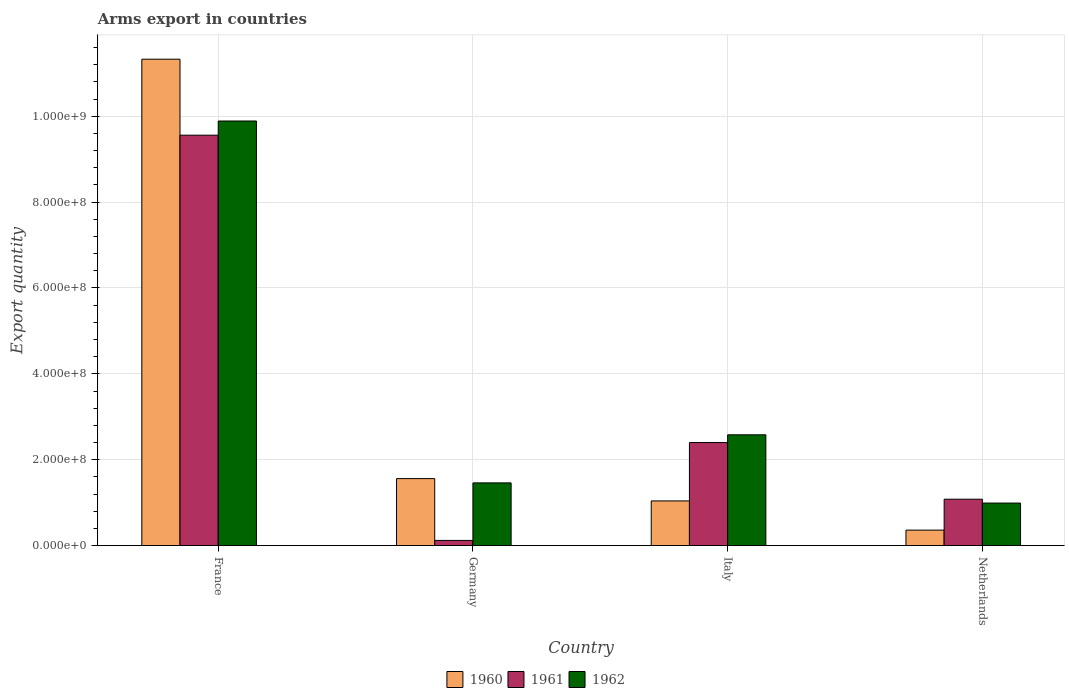How many different coloured bars are there?
Give a very brief answer. 3. How many groups of bars are there?
Provide a succinct answer. 4. How many bars are there on the 3rd tick from the right?
Ensure brevity in your answer.  3. What is the label of the 3rd group of bars from the left?
Provide a succinct answer. Italy. In how many cases, is the number of bars for a given country not equal to the number of legend labels?
Offer a very short reply. 0. What is the total arms export in 1962 in France?
Give a very brief answer. 9.89e+08. Across all countries, what is the maximum total arms export in 1960?
Offer a terse response. 1.13e+09. Across all countries, what is the minimum total arms export in 1962?
Your response must be concise. 9.90e+07. What is the total total arms export in 1962 in the graph?
Offer a very short reply. 1.49e+09. What is the difference between the total arms export in 1961 in France and that in Italy?
Your answer should be compact. 7.16e+08. What is the difference between the total arms export in 1962 in Italy and the total arms export in 1961 in Netherlands?
Make the answer very short. 1.50e+08. What is the average total arms export in 1962 per country?
Offer a terse response. 3.73e+08. What is the difference between the total arms export of/in 1962 and total arms export of/in 1960 in Italy?
Make the answer very short. 1.54e+08. In how many countries, is the total arms export in 1962 greater than 360000000?
Offer a terse response. 1. What is the difference between the highest and the second highest total arms export in 1961?
Give a very brief answer. 7.16e+08. What is the difference between the highest and the lowest total arms export in 1960?
Your answer should be compact. 1.10e+09. In how many countries, is the total arms export in 1962 greater than the average total arms export in 1962 taken over all countries?
Your response must be concise. 1. What does the 1st bar from the right in France represents?
Give a very brief answer. 1962. Is it the case that in every country, the sum of the total arms export in 1960 and total arms export in 1961 is greater than the total arms export in 1962?
Your response must be concise. Yes. Are all the bars in the graph horizontal?
Give a very brief answer. No. Does the graph contain any zero values?
Provide a succinct answer. No. Does the graph contain grids?
Your answer should be very brief. Yes. How many legend labels are there?
Keep it short and to the point. 3. How are the legend labels stacked?
Keep it short and to the point. Horizontal. What is the title of the graph?
Provide a short and direct response. Arms export in countries. What is the label or title of the Y-axis?
Your response must be concise. Export quantity. What is the Export quantity in 1960 in France?
Offer a very short reply. 1.13e+09. What is the Export quantity of 1961 in France?
Offer a terse response. 9.56e+08. What is the Export quantity in 1962 in France?
Keep it short and to the point. 9.89e+08. What is the Export quantity in 1960 in Germany?
Your answer should be very brief. 1.56e+08. What is the Export quantity of 1961 in Germany?
Your response must be concise. 1.20e+07. What is the Export quantity in 1962 in Germany?
Your answer should be compact. 1.46e+08. What is the Export quantity in 1960 in Italy?
Keep it short and to the point. 1.04e+08. What is the Export quantity in 1961 in Italy?
Give a very brief answer. 2.40e+08. What is the Export quantity in 1962 in Italy?
Your answer should be compact. 2.58e+08. What is the Export quantity in 1960 in Netherlands?
Give a very brief answer. 3.60e+07. What is the Export quantity of 1961 in Netherlands?
Offer a terse response. 1.08e+08. What is the Export quantity in 1962 in Netherlands?
Keep it short and to the point. 9.90e+07. Across all countries, what is the maximum Export quantity in 1960?
Your response must be concise. 1.13e+09. Across all countries, what is the maximum Export quantity of 1961?
Offer a terse response. 9.56e+08. Across all countries, what is the maximum Export quantity in 1962?
Provide a short and direct response. 9.89e+08. Across all countries, what is the minimum Export quantity of 1960?
Offer a very short reply. 3.60e+07. Across all countries, what is the minimum Export quantity in 1961?
Provide a succinct answer. 1.20e+07. Across all countries, what is the minimum Export quantity of 1962?
Provide a succinct answer. 9.90e+07. What is the total Export quantity in 1960 in the graph?
Make the answer very short. 1.43e+09. What is the total Export quantity of 1961 in the graph?
Your answer should be compact. 1.32e+09. What is the total Export quantity of 1962 in the graph?
Provide a short and direct response. 1.49e+09. What is the difference between the Export quantity in 1960 in France and that in Germany?
Make the answer very short. 9.77e+08. What is the difference between the Export quantity in 1961 in France and that in Germany?
Your response must be concise. 9.44e+08. What is the difference between the Export quantity of 1962 in France and that in Germany?
Ensure brevity in your answer.  8.43e+08. What is the difference between the Export quantity of 1960 in France and that in Italy?
Offer a terse response. 1.03e+09. What is the difference between the Export quantity of 1961 in France and that in Italy?
Offer a very short reply. 7.16e+08. What is the difference between the Export quantity in 1962 in France and that in Italy?
Provide a succinct answer. 7.31e+08. What is the difference between the Export quantity of 1960 in France and that in Netherlands?
Provide a short and direct response. 1.10e+09. What is the difference between the Export quantity in 1961 in France and that in Netherlands?
Your response must be concise. 8.48e+08. What is the difference between the Export quantity of 1962 in France and that in Netherlands?
Provide a succinct answer. 8.90e+08. What is the difference between the Export quantity of 1960 in Germany and that in Italy?
Keep it short and to the point. 5.20e+07. What is the difference between the Export quantity of 1961 in Germany and that in Italy?
Provide a succinct answer. -2.28e+08. What is the difference between the Export quantity in 1962 in Germany and that in Italy?
Your answer should be very brief. -1.12e+08. What is the difference between the Export quantity in 1960 in Germany and that in Netherlands?
Provide a succinct answer. 1.20e+08. What is the difference between the Export quantity of 1961 in Germany and that in Netherlands?
Provide a succinct answer. -9.60e+07. What is the difference between the Export quantity in 1962 in Germany and that in Netherlands?
Your answer should be compact. 4.70e+07. What is the difference between the Export quantity in 1960 in Italy and that in Netherlands?
Provide a succinct answer. 6.80e+07. What is the difference between the Export quantity in 1961 in Italy and that in Netherlands?
Keep it short and to the point. 1.32e+08. What is the difference between the Export quantity in 1962 in Italy and that in Netherlands?
Your answer should be compact. 1.59e+08. What is the difference between the Export quantity of 1960 in France and the Export quantity of 1961 in Germany?
Keep it short and to the point. 1.12e+09. What is the difference between the Export quantity of 1960 in France and the Export quantity of 1962 in Germany?
Offer a terse response. 9.87e+08. What is the difference between the Export quantity in 1961 in France and the Export quantity in 1962 in Germany?
Your answer should be very brief. 8.10e+08. What is the difference between the Export quantity in 1960 in France and the Export quantity in 1961 in Italy?
Offer a terse response. 8.93e+08. What is the difference between the Export quantity of 1960 in France and the Export quantity of 1962 in Italy?
Give a very brief answer. 8.75e+08. What is the difference between the Export quantity in 1961 in France and the Export quantity in 1962 in Italy?
Your answer should be very brief. 6.98e+08. What is the difference between the Export quantity of 1960 in France and the Export quantity of 1961 in Netherlands?
Make the answer very short. 1.02e+09. What is the difference between the Export quantity in 1960 in France and the Export quantity in 1962 in Netherlands?
Give a very brief answer. 1.03e+09. What is the difference between the Export quantity in 1961 in France and the Export quantity in 1962 in Netherlands?
Keep it short and to the point. 8.57e+08. What is the difference between the Export quantity in 1960 in Germany and the Export quantity in 1961 in Italy?
Provide a short and direct response. -8.40e+07. What is the difference between the Export quantity of 1960 in Germany and the Export quantity of 1962 in Italy?
Offer a very short reply. -1.02e+08. What is the difference between the Export quantity of 1961 in Germany and the Export quantity of 1962 in Italy?
Your response must be concise. -2.46e+08. What is the difference between the Export quantity of 1960 in Germany and the Export quantity of 1961 in Netherlands?
Provide a succinct answer. 4.80e+07. What is the difference between the Export quantity in 1960 in Germany and the Export quantity in 1962 in Netherlands?
Your answer should be very brief. 5.70e+07. What is the difference between the Export quantity in 1961 in Germany and the Export quantity in 1962 in Netherlands?
Keep it short and to the point. -8.70e+07. What is the difference between the Export quantity of 1960 in Italy and the Export quantity of 1962 in Netherlands?
Keep it short and to the point. 5.00e+06. What is the difference between the Export quantity in 1961 in Italy and the Export quantity in 1962 in Netherlands?
Keep it short and to the point. 1.41e+08. What is the average Export quantity in 1960 per country?
Ensure brevity in your answer.  3.57e+08. What is the average Export quantity of 1961 per country?
Your response must be concise. 3.29e+08. What is the average Export quantity in 1962 per country?
Offer a terse response. 3.73e+08. What is the difference between the Export quantity in 1960 and Export quantity in 1961 in France?
Offer a terse response. 1.77e+08. What is the difference between the Export quantity in 1960 and Export quantity in 1962 in France?
Ensure brevity in your answer.  1.44e+08. What is the difference between the Export quantity in 1961 and Export quantity in 1962 in France?
Make the answer very short. -3.30e+07. What is the difference between the Export quantity of 1960 and Export quantity of 1961 in Germany?
Provide a succinct answer. 1.44e+08. What is the difference between the Export quantity in 1960 and Export quantity in 1962 in Germany?
Keep it short and to the point. 1.00e+07. What is the difference between the Export quantity of 1961 and Export quantity of 1962 in Germany?
Your answer should be compact. -1.34e+08. What is the difference between the Export quantity of 1960 and Export quantity of 1961 in Italy?
Your answer should be very brief. -1.36e+08. What is the difference between the Export quantity in 1960 and Export quantity in 1962 in Italy?
Your response must be concise. -1.54e+08. What is the difference between the Export quantity of 1961 and Export quantity of 1962 in Italy?
Your answer should be very brief. -1.80e+07. What is the difference between the Export quantity in 1960 and Export quantity in 1961 in Netherlands?
Your response must be concise. -7.20e+07. What is the difference between the Export quantity in 1960 and Export quantity in 1962 in Netherlands?
Your answer should be compact. -6.30e+07. What is the difference between the Export quantity of 1961 and Export quantity of 1962 in Netherlands?
Your answer should be very brief. 9.00e+06. What is the ratio of the Export quantity in 1960 in France to that in Germany?
Keep it short and to the point. 7.26. What is the ratio of the Export quantity in 1961 in France to that in Germany?
Provide a short and direct response. 79.67. What is the ratio of the Export quantity in 1962 in France to that in Germany?
Your answer should be compact. 6.77. What is the ratio of the Export quantity of 1960 in France to that in Italy?
Your answer should be compact. 10.89. What is the ratio of the Export quantity in 1961 in France to that in Italy?
Provide a short and direct response. 3.98. What is the ratio of the Export quantity in 1962 in France to that in Italy?
Offer a very short reply. 3.83. What is the ratio of the Export quantity in 1960 in France to that in Netherlands?
Provide a succinct answer. 31.47. What is the ratio of the Export quantity in 1961 in France to that in Netherlands?
Offer a terse response. 8.85. What is the ratio of the Export quantity in 1962 in France to that in Netherlands?
Your answer should be compact. 9.99. What is the ratio of the Export quantity of 1960 in Germany to that in Italy?
Your response must be concise. 1.5. What is the ratio of the Export quantity in 1962 in Germany to that in Italy?
Offer a very short reply. 0.57. What is the ratio of the Export quantity in 1960 in Germany to that in Netherlands?
Provide a succinct answer. 4.33. What is the ratio of the Export quantity in 1961 in Germany to that in Netherlands?
Your response must be concise. 0.11. What is the ratio of the Export quantity of 1962 in Germany to that in Netherlands?
Provide a short and direct response. 1.47. What is the ratio of the Export quantity in 1960 in Italy to that in Netherlands?
Make the answer very short. 2.89. What is the ratio of the Export quantity in 1961 in Italy to that in Netherlands?
Give a very brief answer. 2.22. What is the ratio of the Export quantity of 1962 in Italy to that in Netherlands?
Offer a terse response. 2.61. What is the difference between the highest and the second highest Export quantity of 1960?
Your response must be concise. 9.77e+08. What is the difference between the highest and the second highest Export quantity of 1961?
Ensure brevity in your answer.  7.16e+08. What is the difference between the highest and the second highest Export quantity of 1962?
Provide a succinct answer. 7.31e+08. What is the difference between the highest and the lowest Export quantity in 1960?
Offer a terse response. 1.10e+09. What is the difference between the highest and the lowest Export quantity of 1961?
Keep it short and to the point. 9.44e+08. What is the difference between the highest and the lowest Export quantity of 1962?
Provide a succinct answer. 8.90e+08. 